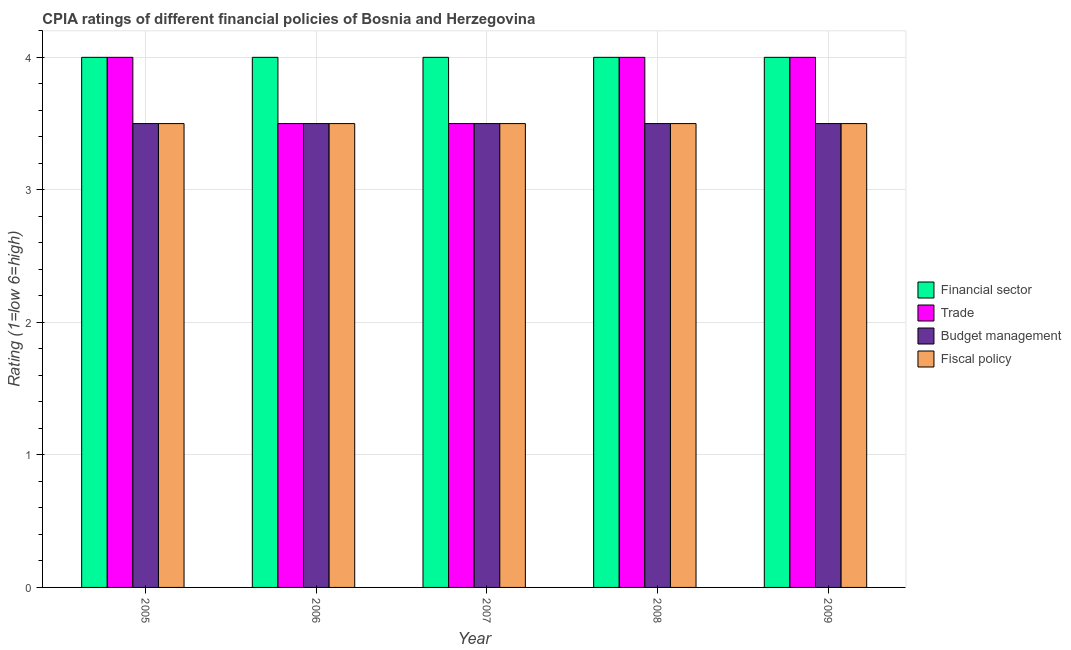How many different coloured bars are there?
Make the answer very short. 4. How many bars are there on the 3rd tick from the left?
Your answer should be compact. 4. What is the cpia rating of budget management in 2009?
Your response must be concise. 3.5. Across all years, what is the minimum cpia rating of trade?
Keep it short and to the point. 3.5. In which year was the cpia rating of trade minimum?
Offer a very short reply. 2006. What is the difference between the cpia rating of fiscal policy in 2007 and that in 2009?
Your answer should be compact. 0. What is the difference between the cpia rating of trade in 2008 and the cpia rating of budget management in 2006?
Ensure brevity in your answer.  0.5. What is the ratio of the cpia rating of trade in 2005 to that in 2007?
Offer a terse response. 1.14. What is the difference between the highest and the second highest cpia rating of financial sector?
Offer a very short reply. 0. What is the difference between the highest and the lowest cpia rating of trade?
Provide a succinct answer. 0.5. Is the sum of the cpia rating of financial sector in 2006 and 2007 greater than the maximum cpia rating of fiscal policy across all years?
Provide a short and direct response. Yes. Is it the case that in every year, the sum of the cpia rating of budget management and cpia rating of fiscal policy is greater than the sum of cpia rating of trade and cpia rating of financial sector?
Offer a very short reply. No. What does the 4th bar from the left in 2008 represents?
Offer a very short reply. Fiscal policy. What does the 2nd bar from the right in 2006 represents?
Make the answer very short. Budget management. Is it the case that in every year, the sum of the cpia rating of financial sector and cpia rating of trade is greater than the cpia rating of budget management?
Give a very brief answer. Yes. How many bars are there?
Keep it short and to the point. 20. Are all the bars in the graph horizontal?
Ensure brevity in your answer.  No. How many years are there in the graph?
Ensure brevity in your answer.  5. How many legend labels are there?
Offer a terse response. 4. How are the legend labels stacked?
Offer a very short reply. Vertical. What is the title of the graph?
Your response must be concise. CPIA ratings of different financial policies of Bosnia and Herzegovina. Does "Japan" appear as one of the legend labels in the graph?
Offer a terse response. No. What is the label or title of the X-axis?
Provide a succinct answer. Year. What is the label or title of the Y-axis?
Provide a succinct answer. Rating (1=low 6=high). What is the Rating (1=low 6=high) in Budget management in 2005?
Make the answer very short. 3.5. What is the Rating (1=low 6=high) in Fiscal policy in 2005?
Provide a short and direct response. 3.5. What is the Rating (1=low 6=high) in Financial sector in 2006?
Your answer should be very brief. 4. What is the Rating (1=low 6=high) in Trade in 2006?
Give a very brief answer. 3.5. What is the Rating (1=low 6=high) of Budget management in 2006?
Provide a short and direct response. 3.5. What is the Rating (1=low 6=high) in Budget management in 2007?
Offer a very short reply. 3.5. What is the Rating (1=low 6=high) in Fiscal policy in 2007?
Keep it short and to the point. 3.5. What is the Rating (1=low 6=high) in Financial sector in 2008?
Your response must be concise. 4. What is the Rating (1=low 6=high) of Budget management in 2008?
Your answer should be very brief. 3.5. What is the Rating (1=low 6=high) of Fiscal policy in 2009?
Provide a short and direct response. 3.5. Across all years, what is the maximum Rating (1=low 6=high) of Financial sector?
Ensure brevity in your answer.  4. Across all years, what is the maximum Rating (1=low 6=high) of Trade?
Give a very brief answer. 4. Across all years, what is the maximum Rating (1=low 6=high) of Budget management?
Keep it short and to the point. 3.5. Across all years, what is the maximum Rating (1=low 6=high) of Fiscal policy?
Make the answer very short. 3.5. Across all years, what is the minimum Rating (1=low 6=high) in Fiscal policy?
Make the answer very short. 3.5. What is the total Rating (1=low 6=high) of Budget management in the graph?
Provide a succinct answer. 17.5. What is the total Rating (1=low 6=high) in Fiscal policy in the graph?
Keep it short and to the point. 17.5. What is the difference between the Rating (1=low 6=high) in Financial sector in 2005 and that in 2006?
Offer a terse response. 0. What is the difference between the Rating (1=low 6=high) in Financial sector in 2005 and that in 2007?
Your answer should be compact. 0. What is the difference between the Rating (1=low 6=high) of Budget management in 2005 and that in 2007?
Your response must be concise. 0. What is the difference between the Rating (1=low 6=high) in Fiscal policy in 2005 and that in 2007?
Your response must be concise. 0. What is the difference between the Rating (1=low 6=high) in Financial sector in 2005 and that in 2008?
Your answer should be very brief. 0. What is the difference between the Rating (1=low 6=high) in Fiscal policy in 2005 and that in 2008?
Ensure brevity in your answer.  0. What is the difference between the Rating (1=low 6=high) in Financial sector in 2005 and that in 2009?
Your answer should be compact. 0. What is the difference between the Rating (1=low 6=high) of Trade in 2005 and that in 2009?
Ensure brevity in your answer.  0. What is the difference between the Rating (1=low 6=high) in Budget management in 2006 and that in 2007?
Provide a short and direct response. 0. What is the difference between the Rating (1=low 6=high) of Fiscal policy in 2006 and that in 2007?
Offer a terse response. 0. What is the difference between the Rating (1=low 6=high) of Trade in 2006 and that in 2008?
Your response must be concise. -0.5. What is the difference between the Rating (1=low 6=high) of Fiscal policy in 2006 and that in 2008?
Ensure brevity in your answer.  0. What is the difference between the Rating (1=low 6=high) of Financial sector in 2006 and that in 2009?
Provide a short and direct response. 0. What is the difference between the Rating (1=low 6=high) in Fiscal policy in 2006 and that in 2009?
Offer a very short reply. 0. What is the difference between the Rating (1=low 6=high) of Financial sector in 2007 and that in 2008?
Offer a terse response. 0. What is the difference between the Rating (1=low 6=high) of Trade in 2007 and that in 2008?
Provide a short and direct response. -0.5. What is the difference between the Rating (1=low 6=high) of Fiscal policy in 2007 and that in 2008?
Provide a short and direct response. 0. What is the difference between the Rating (1=low 6=high) of Financial sector in 2007 and that in 2009?
Give a very brief answer. 0. What is the difference between the Rating (1=low 6=high) of Budget management in 2007 and that in 2009?
Your answer should be very brief. 0. What is the difference between the Rating (1=low 6=high) of Fiscal policy in 2007 and that in 2009?
Ensure brevity in your answer.  0. What is the difference between the Rating (1=low 6=high) of Financial sector in 2008 and that in 2009?
Make the answer very short. 0. What is the difference between the Rating (1=low 6=high) in Financial sector in 2005 and the Rating (1=low 6=high) in Budget management in 2006?
Provide a succinct answer. 0.5. What is the difference between the Rating (1=low 6=high) in Financial sector in 2005 and the Rating (1=low 6=high) in Fiscal policy in 2006?
Provide a succinct answer. 0.5. What is the difference between the Rating (1=low 6=high) of Trade in 2005 and the Rating (1=low 6=high) of Budget management in 2006?
Give a very brief answer. 0.5. What is the difference between the Rating (1=low 6=high) in Financial sector in 2005 and the Rating (1=low 6=high) in Trade in 2007?
Keep it short and to the point. 0.5. What is the difference between the Rating (1=low 6=high) in Financial sector in 2005 and the Rating (1=low 6=high) in Fiscal policy in 2007?
Your response must be concise. 0.5. What is the difference between the Rating (1=low 6=high) of Trade in 2005 and the Rating (1=low 6=high) of Fiscal policy in 2007?
Offer a very short reply. 0.5. What is the difference between the Rating (1=low 6=high) in Financial sector in 2005 and the Rating (1=low 6=high) in Trade in 2008?
Make the answer very short. 0. What is the difference between the Rating (1=low 6=high) in Financial sector in 2005 and the Rating (1=low 6=high) in Fiscal policy in 2008?
Offer a very short reply. 0.5. What is the difference between the Rating (1=low 6=high) of Trade in 2005 and the Rating (1=low 6=high) of Budget management in 2008?
Offer a terse response. 0.5. What is the difference between the Rating (1=low 6=high) of Trade in 2005 and the Rating (1=low 6=high) of Fiscal policy in 2008?
Provide a short and direct response. 0.5. What is the difference between the Rating (1=low 6=high) in Budget management in 2005 and the Rating (1=low 6=high) in Fiscal policy in 2008?
Offer a terse response. 0. What is the difference between the Rating (1=low 6=high) in Financial sector in 2005 and the Rating (1=low 6=high) in Trade in 2009?
Provide a succinct answer. 0. What is the difference between the Rating (1=low 6=high) of Trade in 2005 and the Rating (1=low 6=high) of Fiscal policy in 2009?
Keep it short and to the point. 0.5. What is the difference between the Rating (1=low 6=high) of Budget management in 2005 and the Rating (1=low 6=high) of Fiscal policy in 2009?
Your response must be concise. 0. What is the difference between the Rating (1=low 6=high) in Financial sector in 2006 and the Rating (1=low 6=high) in Trade in 2007?
Offer a very short reply. 0.5. What is the difference between the Rating (1=low 6=high) of Financial sector in 2006 and the Rating (1=low 6=high) of Fiscal policy in 2007?
Keep it short and to the point. 0.5. What is the difference between the Rating (1=low 6=high) in Financial sector in 2006 and the Rating (1=low 6=high) in Fiscal policy in 2008?
Make the answer very short. 0.5. What is the difference between the Rating (1=low 6=high) of Trade in 2006 and the Rating (1=low 6=high) of Budget management in 2008?
Give a very brief answer. 0. What is the difference between the Rating (1=low 6=high) of Trade in 2006 and the Rating (1=low 6=high) of Fiscal policy in 2008?
Offer a very short reply. 0. What is the difference between the Rating (1=low 6=high) in Trade in 2006 and the Rating (1=low 6=high) in Budget management in 2009?
Make the answer very short. 0. What is the difference between the Rating (1=low 6=high) in Budget management in 2006 and the Rating (1=low 6=high) in Fiscal policy in 2009?
Give a very brief answer. 0. What is the difference between the Rating (1=low 6=high) of Financial sector in 2007 and the Rating (1=low 6=high) of Trade in 2008?
Give a very brief answer. 0. What is the difference between the Rating (1=low 6=high) of Financial sector in 2007 and the Rating (1=low 6=high) of Budget management in 2008?
Your answer should be compact. 0.5. What is the difference between the Rating (1=low 6=high) of Trade in 2007 and the Rating (1=low 6=high) of Budget management in 2008?
Ensure brevity in your answer.  0. What is the difference between the Rating (1=low 6=high) of Financial sector in 2007 and the Rating (1=low 6=high) of Trade in 2009?
Give a very brief answer. 0. What is the difference between the Rating (1=low 6=high) in Financial sector in 2007 and the Rating (1=low 6=high) in Fiscal policy in 2009?
Your answer should be very brief. 0.5. What is the difference between the Rating (1=low 6=high) in Trade in 2007 and the Rating (1=low 6=high) in Budget management in 2009?
Provide a succinct answer. 0. What is the difference between the Rating (1=low 6=high) of Trade in 2007 and the Rating (1=low 6=high) of Fiscal policy in 2009?
Keep it short and to the point. 0. What is the difference between the Rating (1=low 6=high) in Financial sector in 2008 and the Rating (1=low 6=high) in Trade in 2009?
Your answer should be very brief. 0. What is the difference between the Rating (1=low 6=high) in Trade in 2008 and the Rating (1=low 6=high) in Budget management in 2009?
Offer a terse response. 0.5. What is the average Rating (1=low 6=high) in Trade per year?
Provide a succinct answer. 3.8. What is the average Rating (1=low 6=high) in Budget management per year?
Keep it short and to the point. 3.5. In the year 2005, what is the difference between the Rating (1=low 6=high) of Financial sector and Rating (1=low 6=high) of Fiscal policy?
Offer a very short reply. 0.5. In the year 2005, what is the difference between the Rating (1=low 6=high) of Trade and Rating (1=low 6=high) of Budget management?
Give a very brief answer. 0.5. In the year 2005, what is the difference between the Rating (1=low 6=high) of Budget management and Rating (1=low 6=high) of Fiscal policy?
Provide a short and direct response. 0. In the year 2006, what is the difference between the Rating (1=low 6=high) of Financial sector and Rating (1=low 6=high) of Budget management?
Offer a terse response. 0.5. In the year 2006, what is the difference between the Rating (1=low 6=high) of Trade and Rating (1=low 6=high) of Budget management?
Provide a succinct answer. 0. In the year 2006, what is the difference between the Rating (1=low 6=high) of Trade and Rating (1=low 6=high) of Fiscal policy?
Offer a terse response. 0. In the year 2006, what is the difference between the Rating (1=low 6=high) in Budget management and Rating (1=low 6=high) in Fiscal policy?
Your answer should be compact. 0. In the year 2007, what is the difference between the Rating (1=low 6=high) of Financial sector and Rating (1=low 6=high) of Budget management?
Your answer should be compact. 0.5. In the year 2007, what is the difference between the Rating (1=low 6=high) in Financial sector and Rating (1=low 6=high) in Fiscal policy?
Make the answer very short. 0.5. In the year 2007, what is the difference between the Rating (1=low 6=high) of Trade and Rating (1=low 6=high) of Budget management?
Give a very brief answer. 0. In the year 2008, what is the difference between the Rating (1=low 6=high) in Financial sector and Rating (1=low 6=high) in Trade?
Ensure brevity in your answer.  0. In the year 2008, what is the difference between the Rating (1=low 6=high) in Financial sector and Rating (1=low 6=high) in Fiscal policy?
Give a very brief answer. 0.5. In the year 2008, what is the difference between the Rating (1=low 6=high) in Trade and Rating (1=low 6=high) in Budget management?
Make the answer very short. 0.5. In the year 2008, what is the difference between the Rating (1=low 6=high) of Trade and Rating (1=low 6=high) of Fiscal policy?
Ensure brevity in your answer.  0.5. In the year 2008, what is the difference between the Rating (1=low 6=high) of Budget management and Rating (1=low 6=high) of Fiscal policy?
Your answer should be very brief. 0. In the year 2009, what is the difference between the Rating (1=low 6=high) in Financial sector and Rating (1=low 6=high) in Trade?
Provide a short and direct response. 0. In the year 2009, what is the difference between the Rating (1=low 6=high) of Financial sector and Rating (1=low 6=high) of Budget management?
Offer a terse response. 0.5. In the year 2009, what is the difference between the Rating (1=low 6=high) in Budget management and Rating (1=low 6=high) in Fiscal policy?
Provide a succinct answer. 0. What is the ratio of the Rating (1=low 6=high) of Fiscal policy in 2005 to that in 2006?
Ensure brevity in your answer.  1. What is the ratio of the Rating (1=low 6=high) in Trade in 2005 to that in 2007?
Offer a very short reply. 1.14. What is the ratio of the Rating (1=low 6=high) in Fiscal policy in 2005 to that in 2007?
Offer a terse response. 1. What is the ratio of the Rating (1=low 6=high) in Financial sector in 2005 to that in 2008?
Give a very brief answer. 1. What is the ratio of the Rating (1=low 6=high) in Budget management in 2005 to that in 2008?
Ensure brevity in your answer.  1. What is the ratio of the Rating (1=low 6=high) of Trade in 2005 to that in 2009?
Ensure brevity in your answer.  1. What is the ratio of the Rating (1=low 6=high) in Budget management in 2005 to that in 2009?
Your answer should be compact. 1. What is the ratio of the Rating (1=low 6=high) of Fiscal policy in 2005 to that in 2009?
Give a very brief answer. 1. What is the ratio of the Rating (1=low 6=high) in Financial sector in 2006 to that in 2007?
Your response must be concise. 1. What is the ratio of the Rating (1=low 6=high) of Budget management in 2006 to that in 2007?
Offer a terse response. 1. What is the ratio of the Rating (1=low 6=high) of Fiscal policy in 2006 to that in 2007?
Make the answer very short. 1. What is the ratio of the Rating (1=low 6=high) of Financial sector in 2006 to that in 2009?
Your answer should be very brief. 1. What is the ratio of the Rating (1=low 6=high) in Fiscal policy in 2006 to that in 2009?
Make the answer very short. 1. What is the ratio of the Rating (1=low 6=high) in Financial sector in 2007 to that in 2008?
Keep it short and to the point. 1. What is the ratio of the Rating (1=low 6=high) of Fiscal policy in 2007 to that in 2008?
Your answer should be very brief. 1. What is the ratio of the Rating (1=low 6=high) in Financial sector in 2008 to that in 2009?
Offer a terse response. 1. What is the ratio of the Rating (1=low 6=high) of Trade in 2008 to that in 2009?
Provide a short and direct response. 1. What is the ratio of the Rating (1=low 6=high) in Fiscal policy in 2008 to that in 2009?
Provide a short and direct response. 1. What is the difference between the highest and the second highest Rating (1=low 6=high) of Trade?
Offer a terse response. 0. What is the difference between the highest and the second highest Rating (1=low 6=high) of Budget management?
Provide a short and direct response. 0. What is the difference between the highest and the second highest Rating (1=low 6=high) in Fiscal policy?
Give a very brief answer. 0. What is the difference between the highest and the lowest Rating (1=low 6=high) in Trade?
Ensure brevity in your answer.  0.5. 